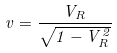<formula> <loc_0><loc_0><loc_500><loc_500>v = \frac { V _ { R } } { \sqrt { 1 - V _ { R } ^ { 2 } } }</formula> 